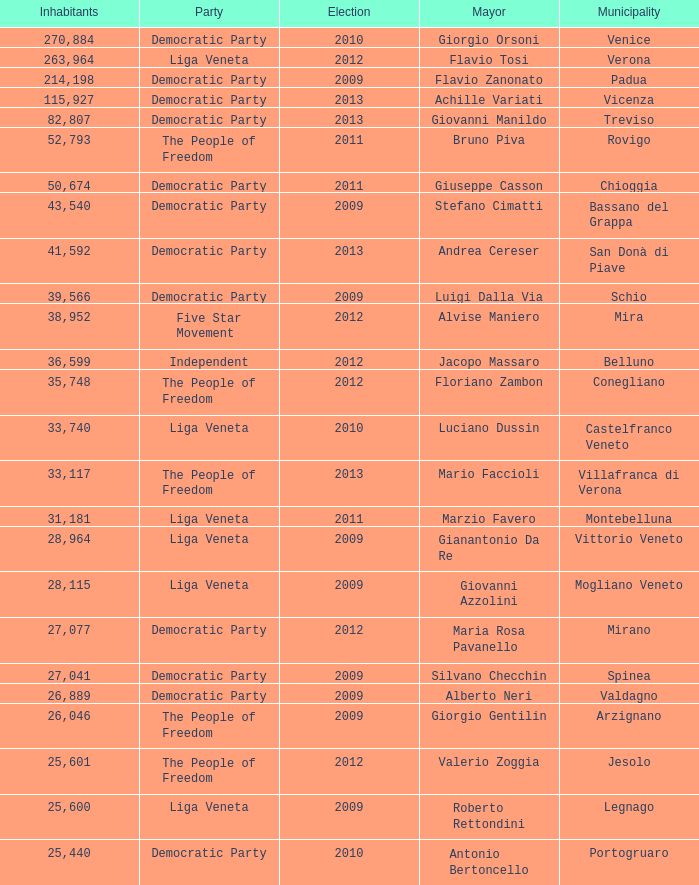What party was achille variati afilliated with? Democratic Party. 